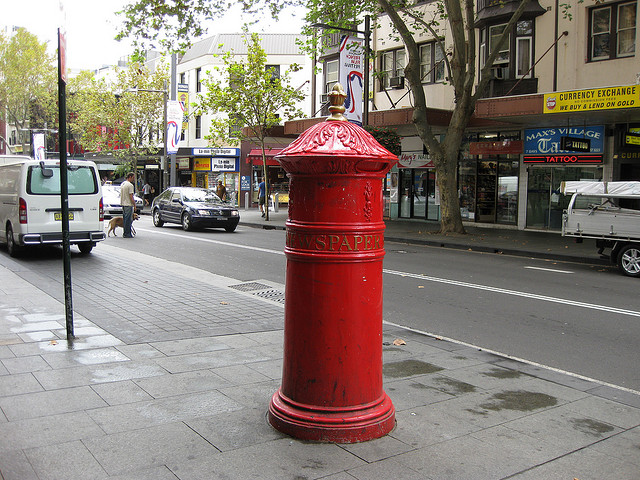Identify the text contained in this image. NEWSPAPER PAPER CURRENCY EXCHANGE TATTOO ON 